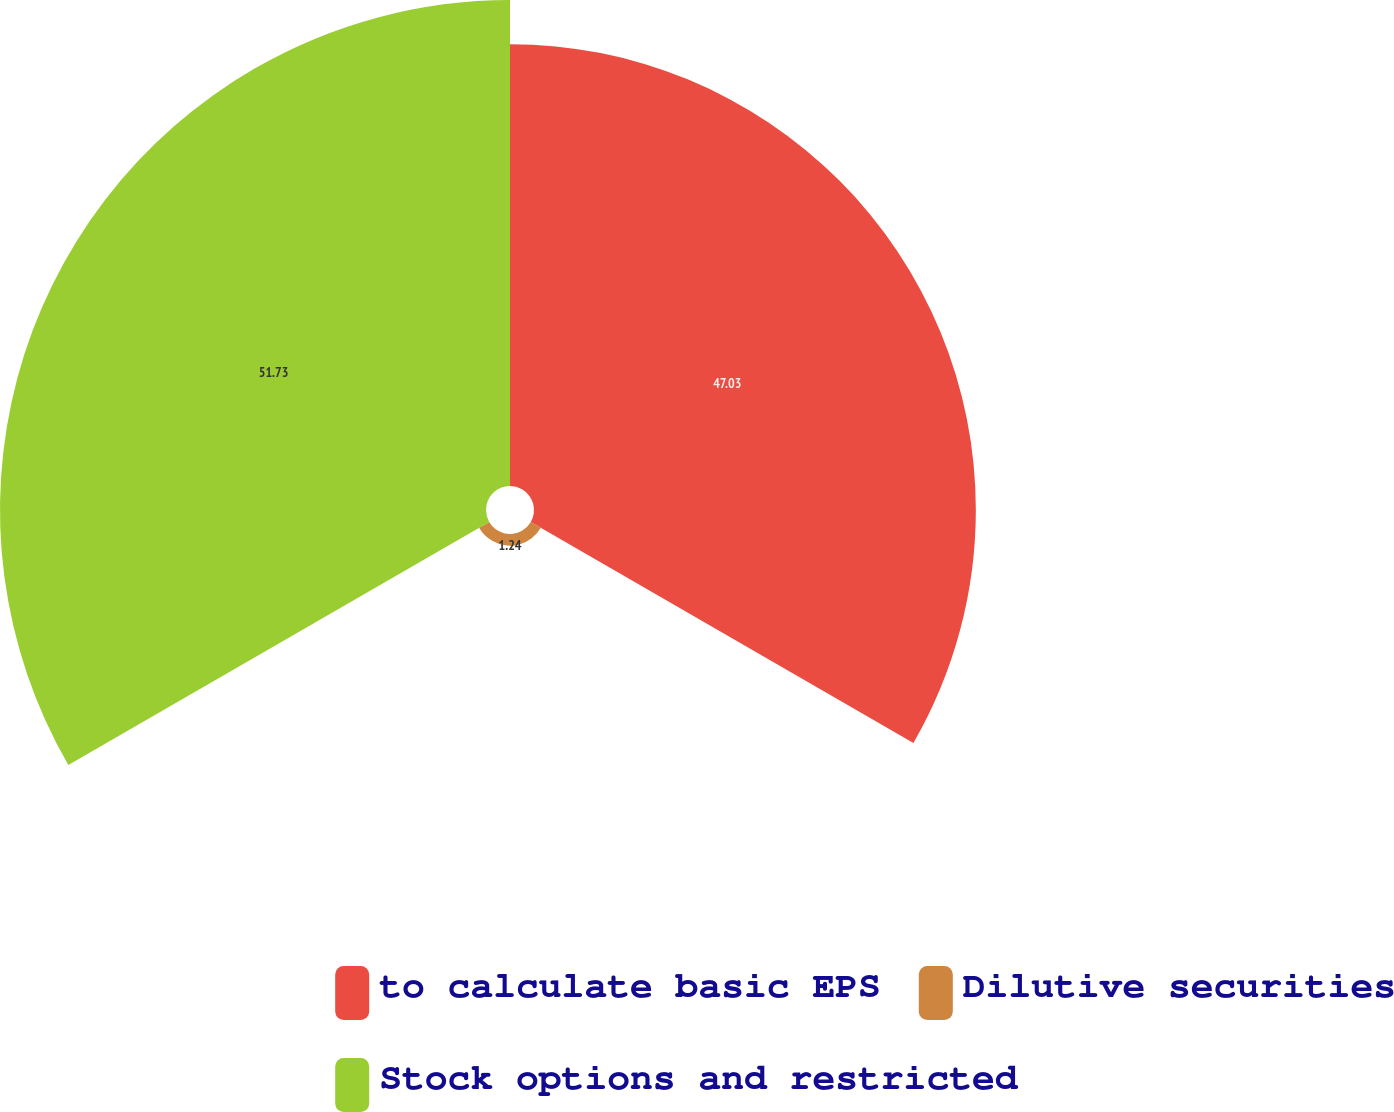<chart> <loc_0><loc_0><loc_500><loc_500><pie_chart><fcel>to calculate basic EPS<fcel>Dilutive securities<fcel>Stock options and restricted<nl><fcel>47.03%<fcel>1.24%<fcel>51.73%<nl></chart> 